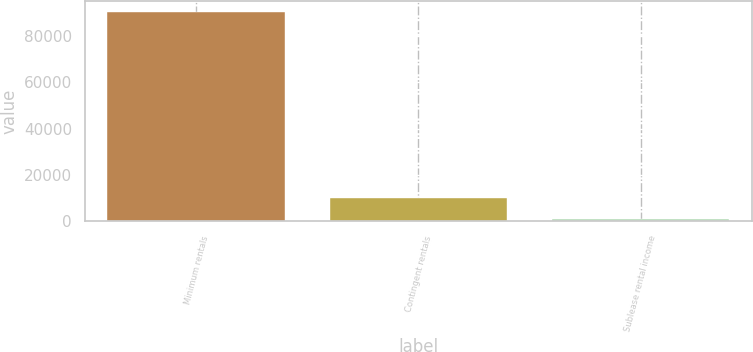Convert chart. <chart><loc_0><loc_0><loc_500><loc_500><bar_chart><fcel>Minimum rentals<fcel>Contingent rentals<fcel>Sublease rental income<nl><fcel>90547<fcel>10135.6<fcel>1201<nl></chart> 